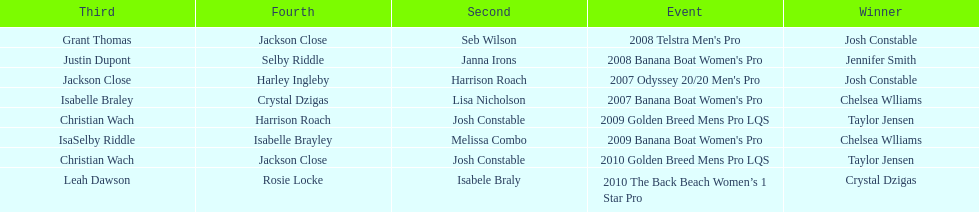How many times was josh constable second? 2. 